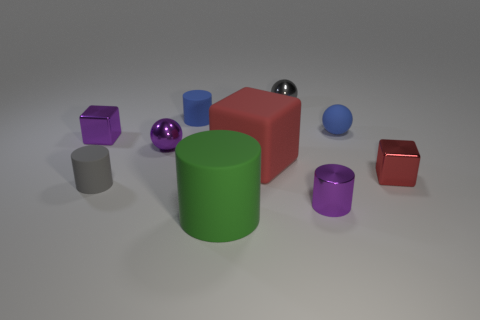Subtract 1 cylinders. How many cylinders are left? 3 Subtract all cylinders. How many objects are left? 6 Subtract all tiny red cubes. Subtract all purple cylinders. How many objects are left? 8 Add 5 rubber blocks. How many rubber blocks are left? 6 Add 8 small green objects. How many small green objects exist? 8 Subtract 1 purple cubes. How many objects are left? 9 